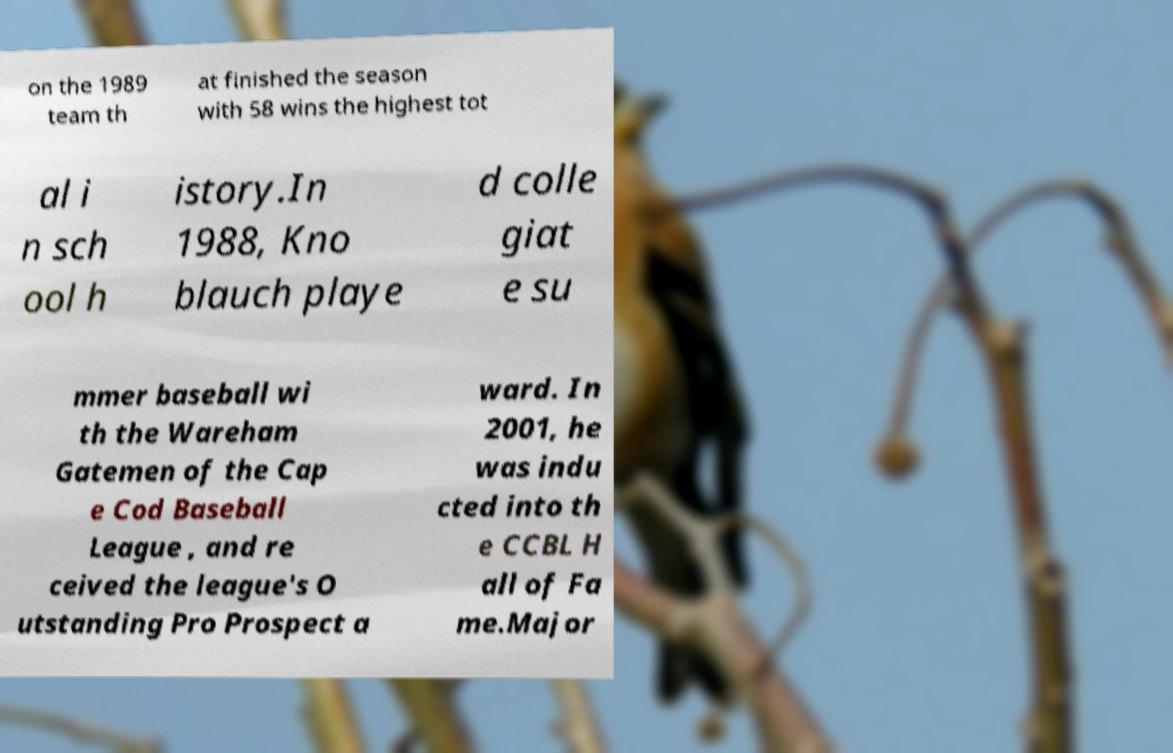Can you accurately transcribe the text from the provided image for me? on the 1989 team th at finished the season with 58 wins the highest tot al i n sch ool h istory.In 1988, Kno blauch playe d colle giat e su mmer baseball wi th the Wareham Gatemen of the Cap e Cod Baseball League , and re ceived the league's O utstanding Pro Prospect a ward. In 2001, he was indu cted into th e CCBL H all of Fa me.Major 